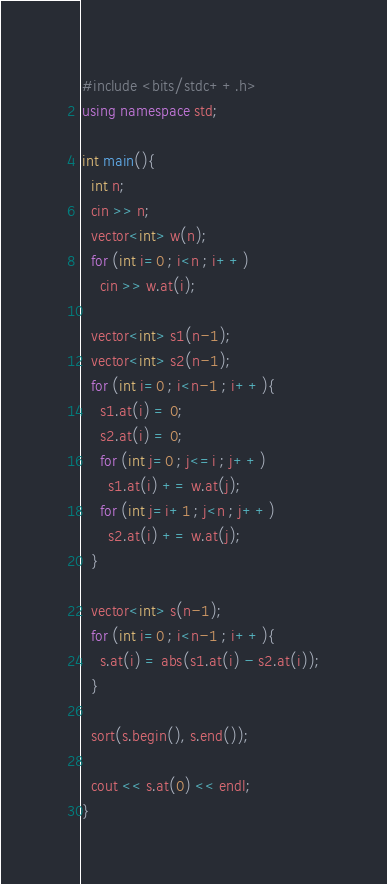<code> <loc_0><loc_0><loc_500><loc_500><_C++_>#include <bits/stdc++.h>
using namespace std;

int main(){
  int n;
  cin >> n;
  vector<int> w(n);
  for (int i=0 ; i<n ; i++)
    cin >> w.at(i);
  
  vector<int> s1(n-1);
  vector<int> s2(n-1);
  for (int i=0 ; i<n-1 ; i++){
    s1.at(i) = 0;
    s2.at(i) = 0;
    for (int j=0 ; j<=i ; j++)
      s1.at(i) += w.at(j);
    for (int j=i+1 ; j<n ; j++)
      s2.at(i) += w.at(j);
  }
  
  vector<int> s(n-1);
  for (int i=0 ; i<n-1 ; i++){
    s.at(i) = abs(s1.at(i) - s2.at(i));
  }
  
  sort(s.begin(), s.end());
  
  cout << s.at(0) << endl;
}</code> 